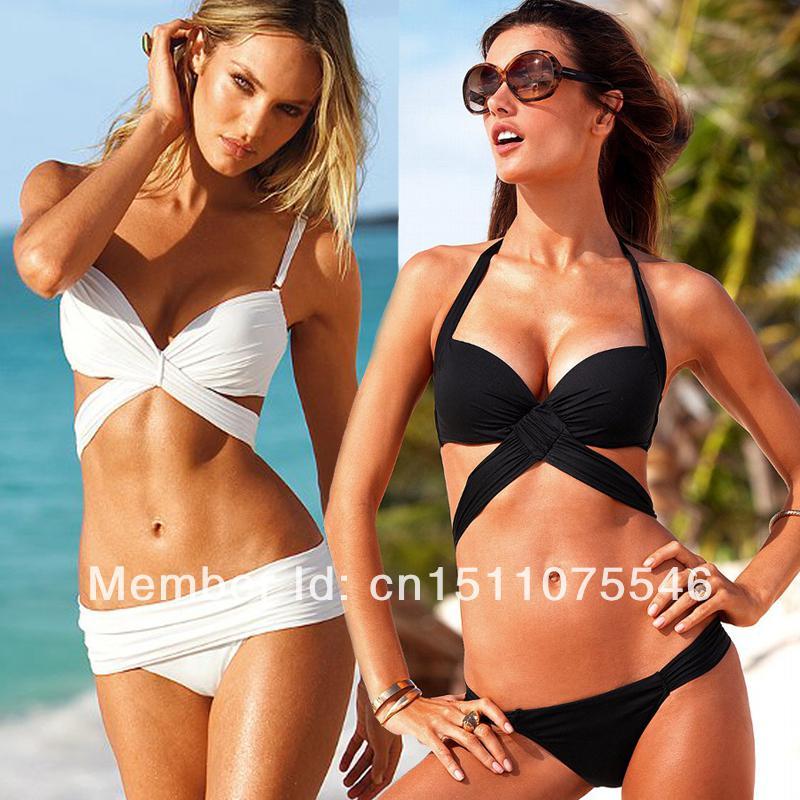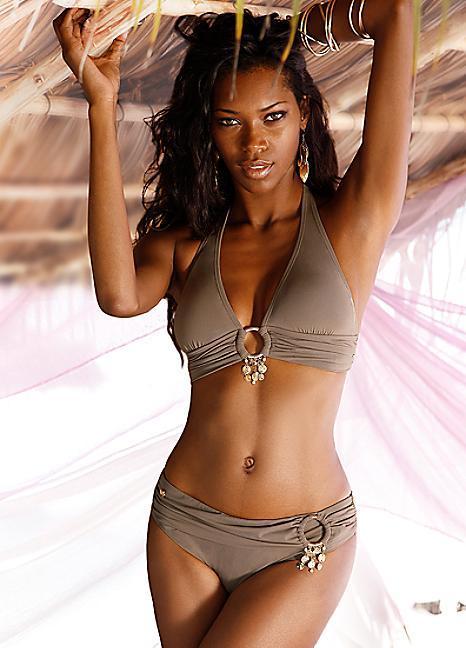The first image is the image on the left, the second image is the image on the right. For the images displayed, is the sentence "Thr right image shows a blonde bikini model with at least one arm raised to her hair and her hip jutted to the right." factually correct? Answer yes or no. No. 